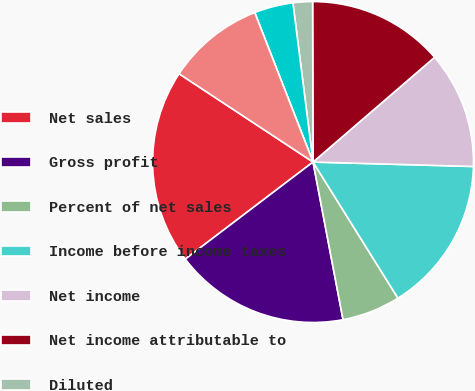Convert chart to OTSL. <chart><loc_0><loc_0><loc_500><loc_500><pie_chart><fcel>Net sales<fcel>Gross profit<fcel>Percent of net sales<fcel>Income before income taxes<fcel>Net income<fcel>Net income attributable to<fcel>Diluted<fcel>Basic<fcel>Cash dividends declared per<fcel>High<nl><fcel>19.61%<fcel>17.65%<fcel>5.88%<fcel>15.68%<fcel>11.76%<fcel>13.72%<fcel>1.96%<fcel>3.92%<fcel>0.0%<fcel>9.8%<nl></chart> 